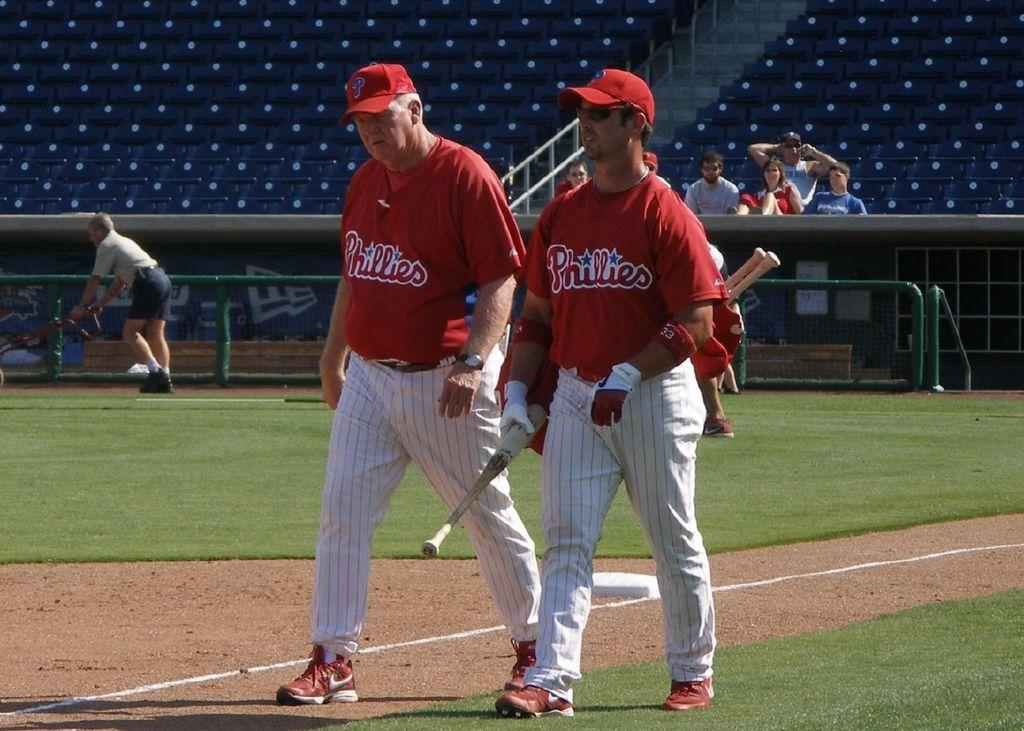<image>
Present a compact description of the photo's key features. A couple of guys in baseball uniforms that say Phillies on it 